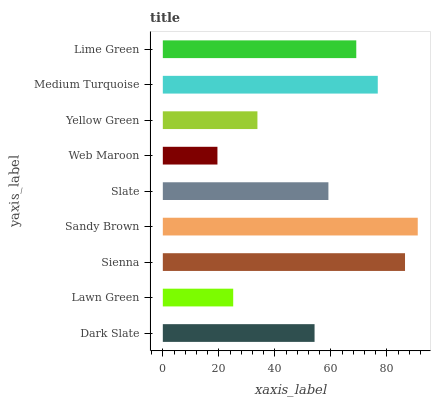Is Web Maroon the minimum?
Answer yes or no. Yes. Is Sandy Brown the maximum?
Answer yes or no. Yes. Is Lawn Green the minimum?
Answer yes or no. No. Is Lawn Green the maximum?
Answer yes or no. No. Is Dark Slate greater than Lawn Green?
Answer yes or no. Yes. Is Lawn Green less than Dark Slate?
Answer yes or no. Yes. Is Lawn Green greater than Dark Slate?
Answer yes or no. No. Is Dark Slate less than Lawn Green?
Answer yes or no. No. Is Slate the high median?
Answer yes or no. Yes. Is Slate the low median?
Answer yes or no. Yes. Is Sienna the high median?
Answer yes or no. No. Is Lime Green the low median?
Answer yes or no. No. 